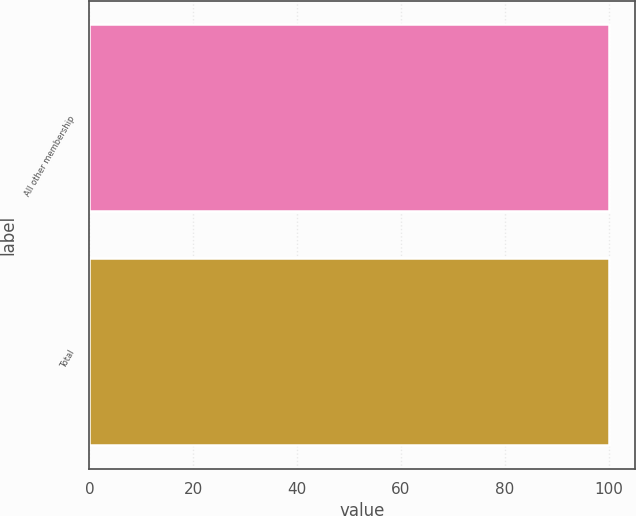<chart> <loc_0><loc_0><loc_500><loc_500><bar_chart><fcel>All other membership<fcel>Total<nl><fcel>100<fcel>100.1<nl></chart> 